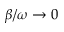<formula> <loc_0><loc_0><loc_500><loc_500>\beta / \omega \to 0</formula> 